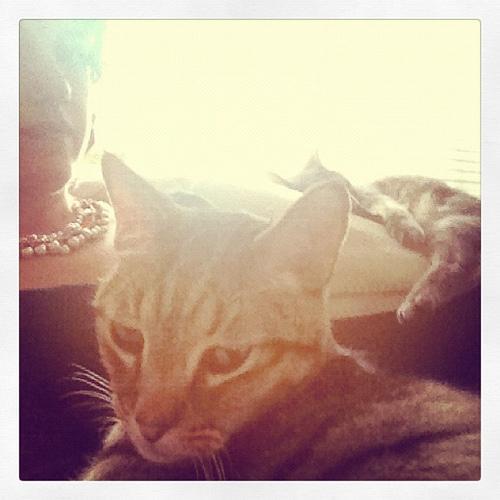How many cats are in the picture?
Give a very brief answer. 2. 